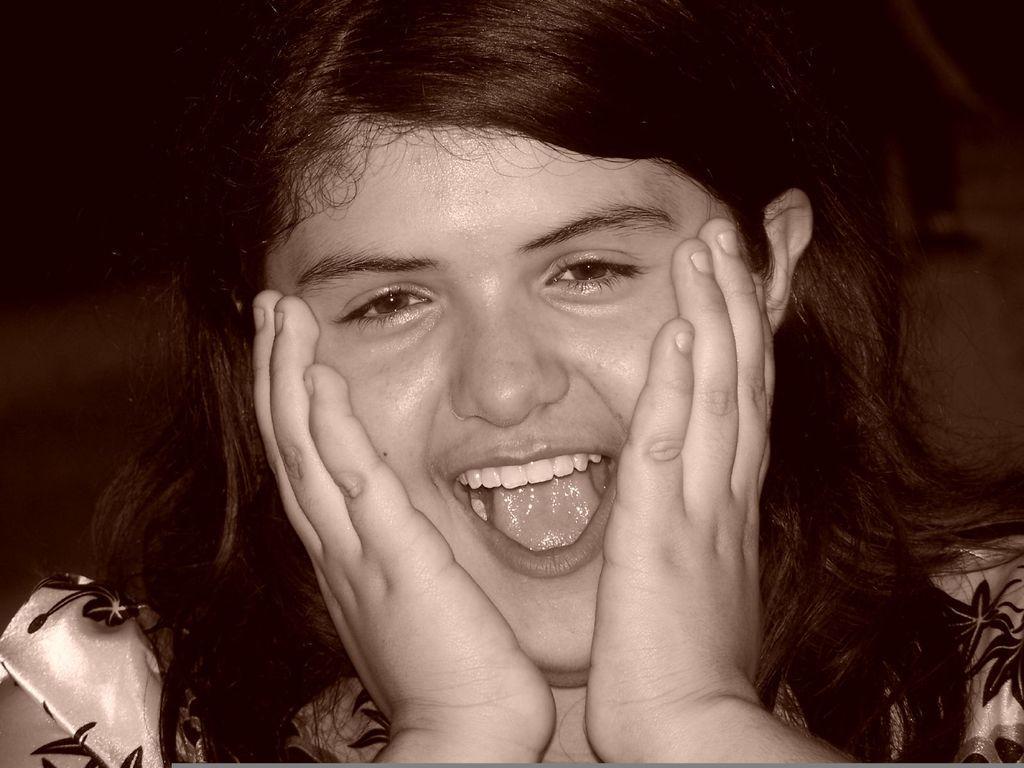Describe this image in one or two sentences. In this picture I can see a woman smiling, and there is blur background. 